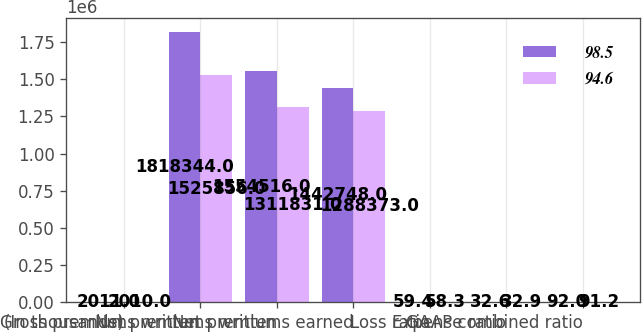Convert chart to OTSL. <chart><loc_0><loc_0><loc_500><loc_500><stacked_bar_chart><ecel><fcel>(In thousands)<fcel>Gross premiums written<fcel>Net premiums written<fcel>Net premiums earned<fcel>Loss ratio<fcel>Expense ratio<fcel>GAAP combined ratio<nl><fcel>98.5<fcel>2011<fcel>1.81834e+06<fcel>1.55452e+06<fcel>1.44275e+06<fcel>59.4<fcel>32.6<fcel>92<nl><fcel>94.6<fcel>2010<fcel>1.52586e+06<fcel>1.31183e+06<fcel>1.28837e+06<fcel>58.3<fcel>32.9<fcel>91.2<nl></chart> 